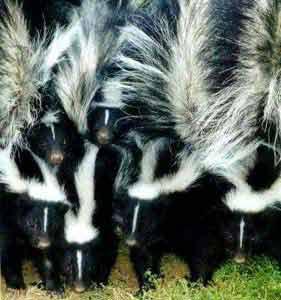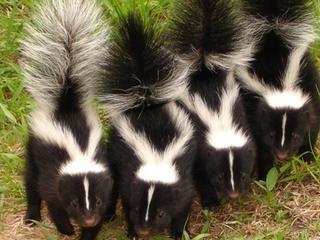The first image is the image on the left, the second image is the image on the right. Examine the images to the left and right. Is the description "At least one skunk is eating." accurate? Answer yes or no. No. 